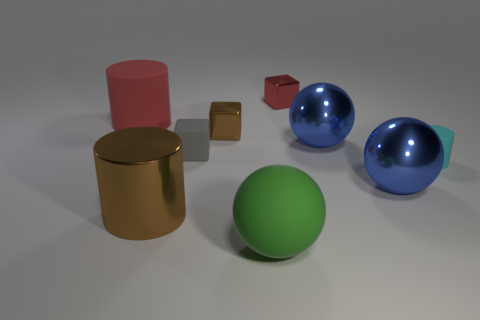Is the material of the big blue thing in front of the tiny rubber cylinder the same as the big sphere behind the cyan matte thing? The big blue object appears to be a glossy, possibly plastic material, which does reflect light similarly to the larger sphere in the background. However, without specific information on the actual materials, we can say they look similar in terms of shine and reflectiveness, suggesting they might be made of similar substances. 